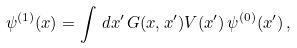<formula> <loc_0><loc_0><loc_500><loc_500>\psi ^ { ( 1 ) } ( x ) = \int \, d x ^ { \prime } \, G ( x , x ^ { \prime } ) V ( x ^ { \prime } ) \, \psi ^ { ( 0 ) } ( x ^ { \prime } ) \, ,</formula> 